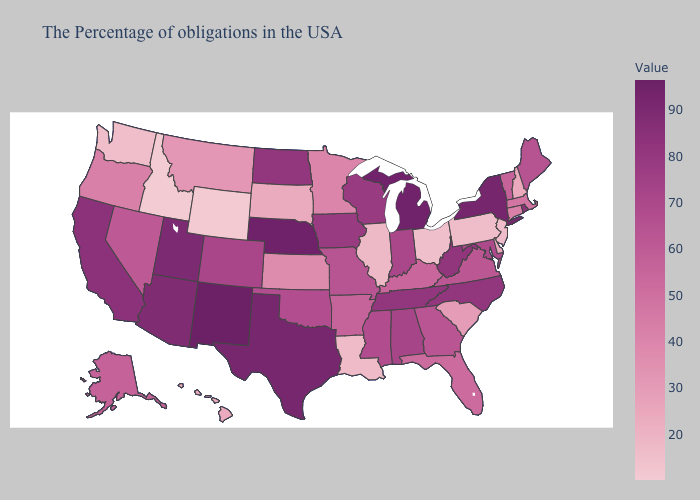Does Missouri have the highest value in the USA?
Short answer required. No. Does Kentucky have a higher value than Wyoming?
Give a very brief answer. Yes. Among the states that border Rhode Island , which have the highest value?
Be succinct. Massachusetts. Among the states that border Kansas , which have the highest value?
Write a very short answer. Nebraska. 